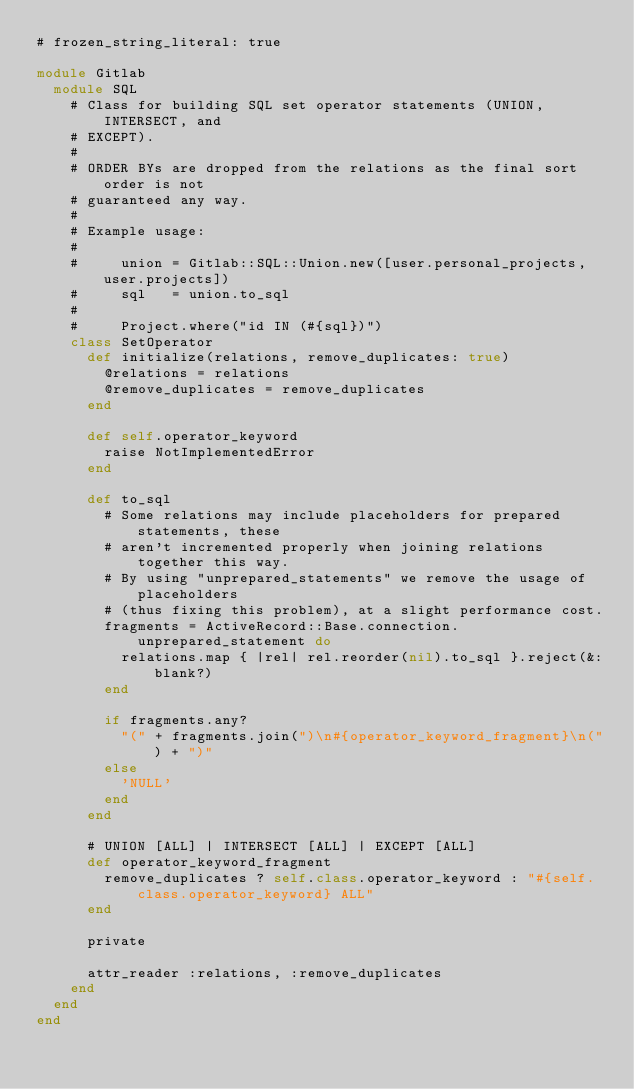Convert code to text. <code><loc_0><loc_0><loc_500><loc_500><_Ruby_># frozen_string_literal: true

module Gitlab
  module SQL
    # Class for building SQL set operator statements (UNION, INTERSECT, and
    # EXCEPT).
    #
    # ORDER BYs are dropped from the relations as the final sort order is not
    # guaranteed any way.
    #
    # Example usage:
    #
    #     union = Gitlab::SQL::Union.new([user.personal_projects, user.projects])
    #     sql   = union.to_sql
    #
    #     Project.where("id IN (#{sql})")
    class SetOperator
      def initialize(relations, remove_duplicates: true)
        @relations = relations
        @remove_duplicates = remove_duplicates
      end

      def self.operator_keyword
        raise NotImplementedError
      end

      def to_sql
        # Some relations may include placeholders for prepared statements, these
        # aren't incremented properly when joining relations together this way.
        # By using "unprepared_statements" we remove the usage of placeholders
        # (thus fixing this problem), at a slight performance cost.
        fragments = ActiveRecord::Base.connection.unprepared_statement do
          relations.map { |rel| rel.reorder(nil).to_sql }.reject(&:blank?)
        end

        if fragments.any?
          "(" + fragments.join(")\n#{operator_keyword_fragment}\n(") + ")"
        else
          'NULL'
        end
      end

      # UNION [ALL] | INTERSECT [ALL] | EXCEPT [ALL]
      def operator_keyword_fragment
        remove_duplicates ? self.class.operator_keyword : "#{self.class.operator_keyword} ALL"
      end

      private

      attr_reader :relations, :remove_duplicates
    end
  end
end
</code> 